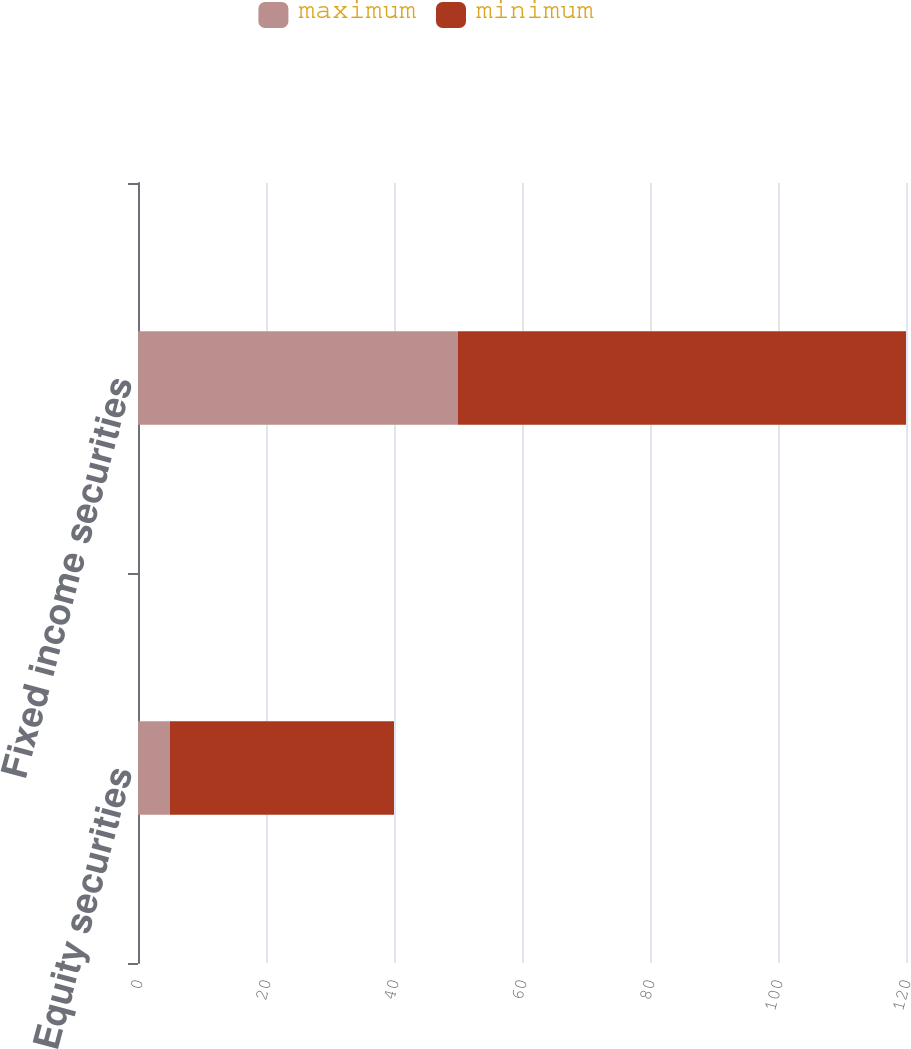<chart> <loc_0><loc_0><loc_500><loc_500><stacked_bar_chart><ecel><fcel>Equity securities<fcel>Fixed income securities<nl><fcel>maximum<fcel>5<fcel>50<nl><fcel>minimum<fcel>35<fcel>70<nl></chart> 